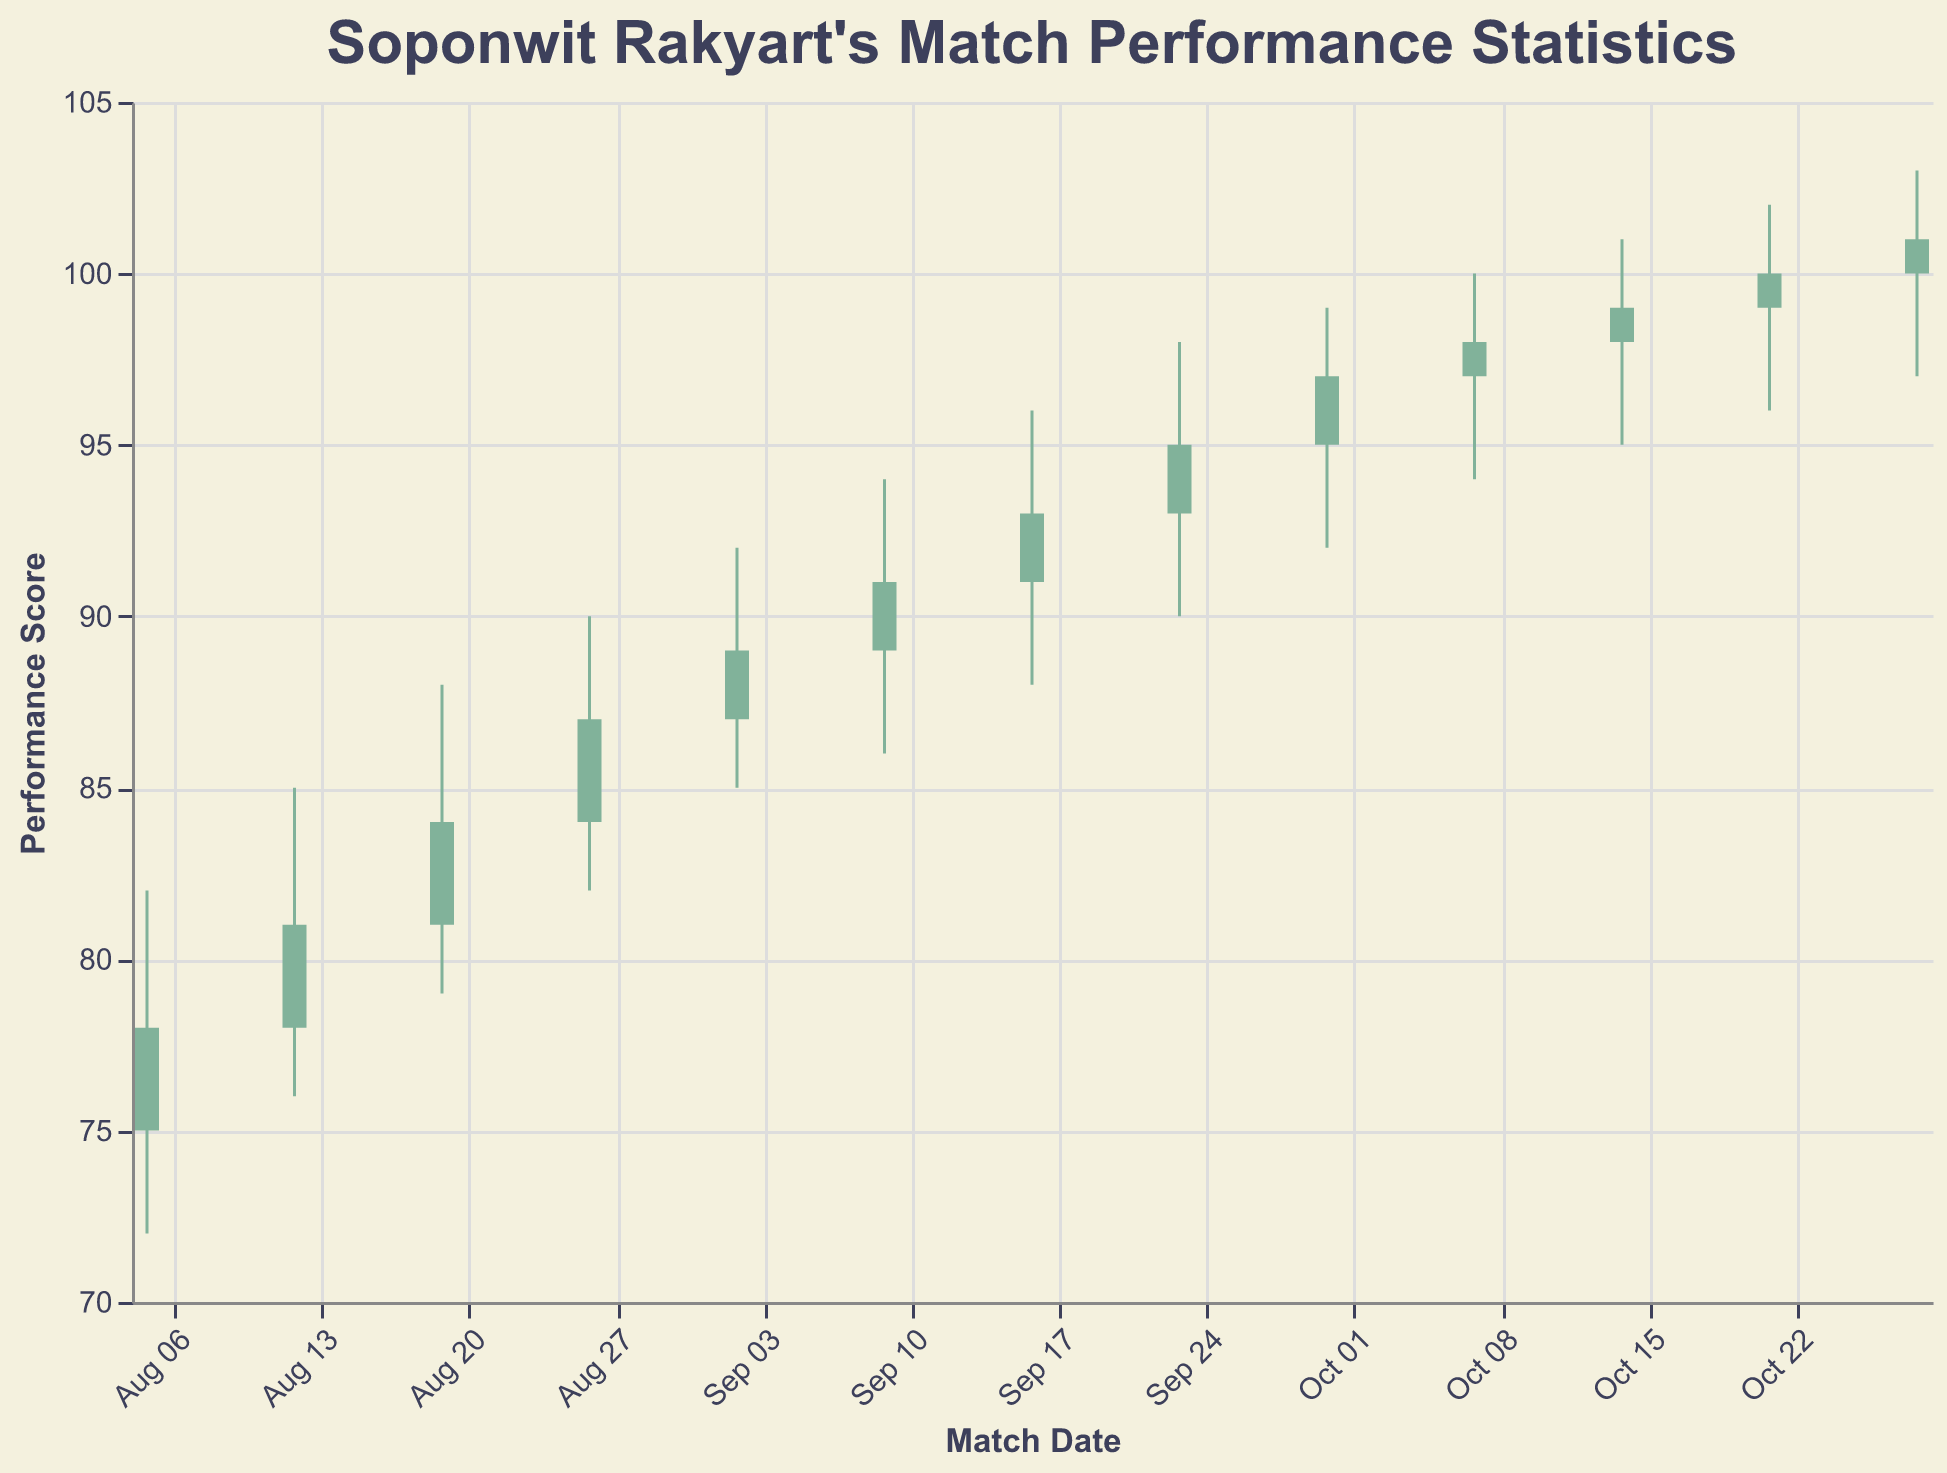What's the title of the figure? The title is displayed at the top of the chart, providing a quick summary of what the figure represents. It reads "Soponwit Rakyart's Match Performance Statistics".
Answer: Soponwit Rakyart's Match Performance Statistics How many match data points are displayed in total in the figure? By counting each data entry along the x-axis, which corresponds to each match date, we can see that there are 13 data points (one per match date).
Answer: 13 On which date did Soponwit Rakyart have the highest high performance score? By examining the "High" values on the y-axis, the highest value is 103, which corresponds to the date 2023-10-28.
Answer: 2023-10-28 What is the performance score range for the match on 2023-09-09? According to the figure, for 2023-09-09, the "Low" value is 86 and the "High" value is 94.
Answer: 86 to 94 Which date had the lowest open performance score? The lowest "Open" value in the chart is 75, which corresponds to the date 2023-08-05.
Answer: 2023-08-05 What is the overall trend of Soponwit Rakyart's performance from August to October? By looking at the "Close" values over time, we observe an upward trend where the closing performance starts from 78 (in August) and goes up to 101 (in October).
Answer: Upward trend Compare the performance scores on 2023-09-09 and 2023-09-30, which one saw a greater increase from the open to the close? For 2023-09-09: Open is 89, Close is 91 (increase of 2). For 2023-09-30: Open is 95, Close is 97 (increase of 2). Both dates have an equal increase in scores from open to close.
Answer: Both are equal Calculate the average closing score for the matches in September. Close scores in September: 89, 91, 93, 95. Sum = 89 + 91 + 93 + 95 = 368. Average = 368 / 4 = 92
Answer: 92 Which dates had a closing performance score higher than 95? Examining the data, the dates with closing scores higher than 95 are: 2023-09-30, 2023-10-07, 2023-10-14, 2023-10-21, 2023-10-28.
Answer: 2023-09-30, 2023-10-07, 2023-10-14, 2023-10-21, 2023-10-28 